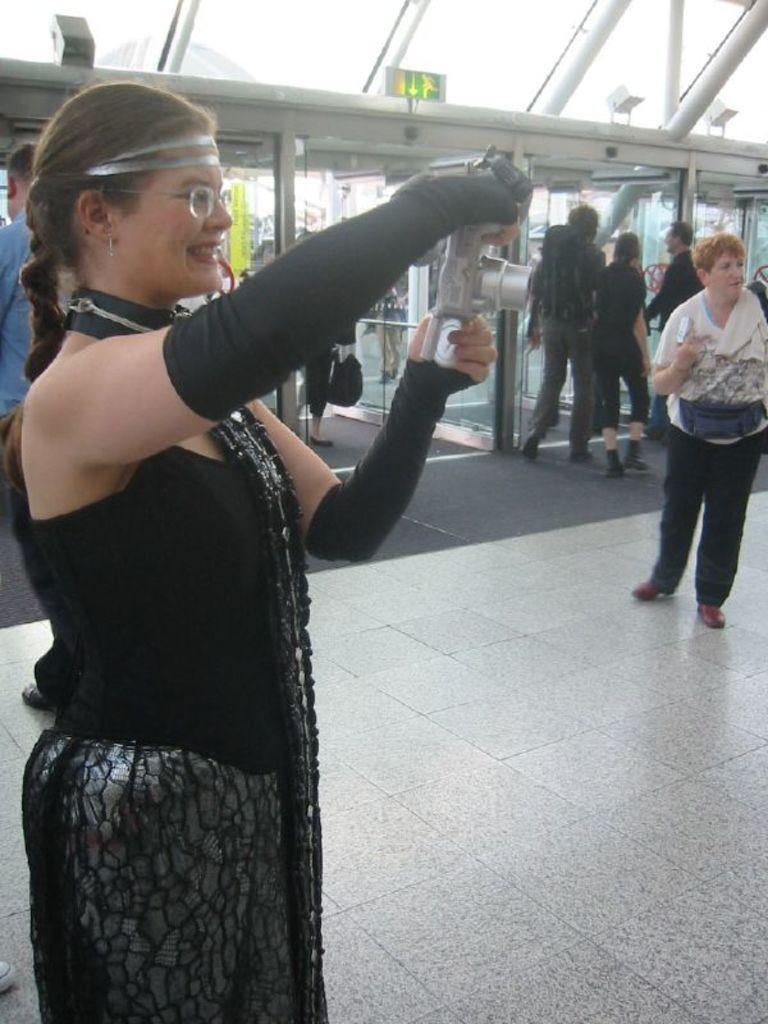Who is the main subject in the image? There is a woman in the image. What is the woman wearing? The woman is wearing a black dress and spectacles. What is the woman holding in her hands? The woman is holding a camera in her hands. What can be seen in the background of the image? There are people walking in the background of the image. What month is it in the image? The month is not mentioned or depicted in the image, so it cannot be determined. 